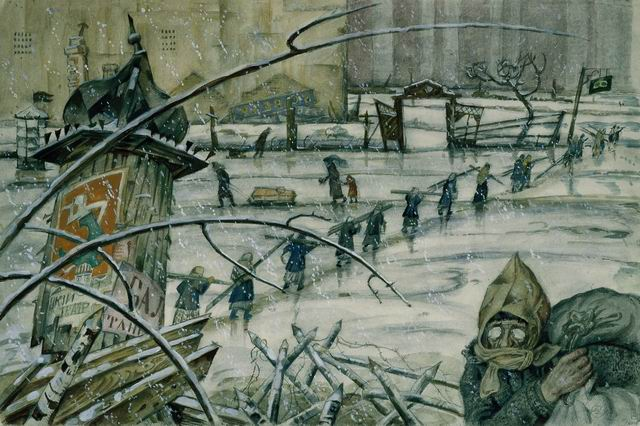Create a fictional dialogue between two characters in the image. Character A: 'How much further do we have to go?' 
Character B: 'Not far. Just over the bridge and we'll find shelter.' 
Character A: 'I hope you’re right. The cold is unbearable, and I worry about the children.' 
Character B: 'We'll make it. We have to. Just keep moving, one step at a time. I’ve heard there's a place where we can get warm and have some food.' 
Character A: 'I can barely remember what a warm meal feels like. But for now, we must stay strong. For the children and for ourselves.' 